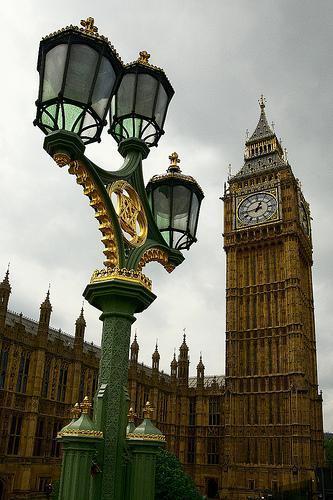How many lights are on the lamp post?
Give a very brief answer. 3. 